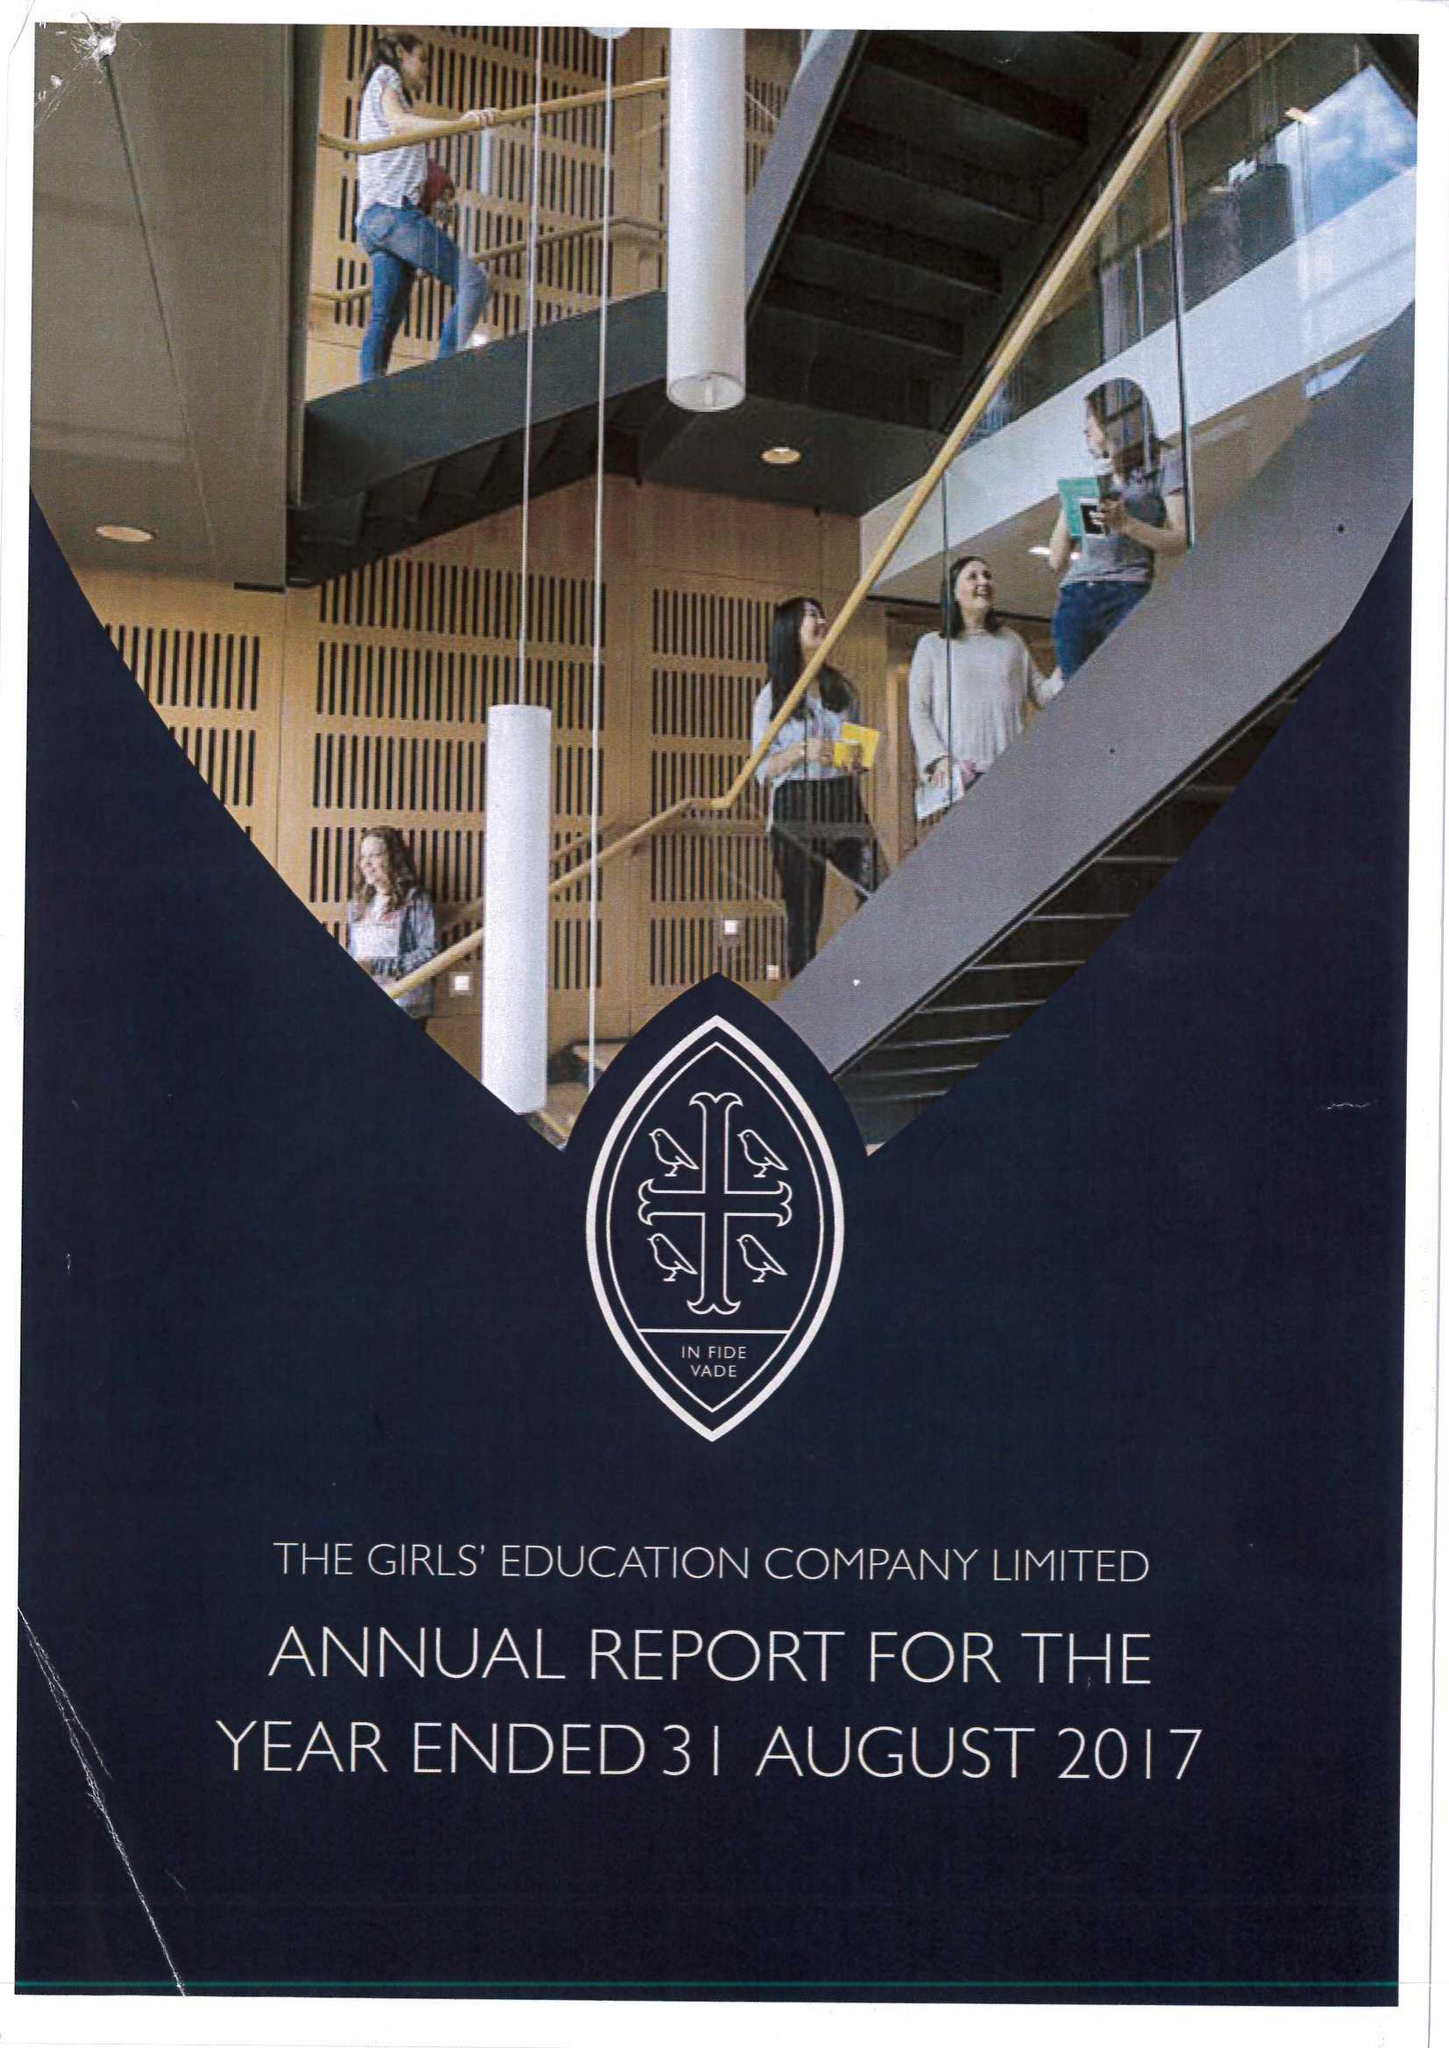What is the value for the spending_annually_in_british_pounds?
Answer the question using a single word or phrase. 21184000.00 